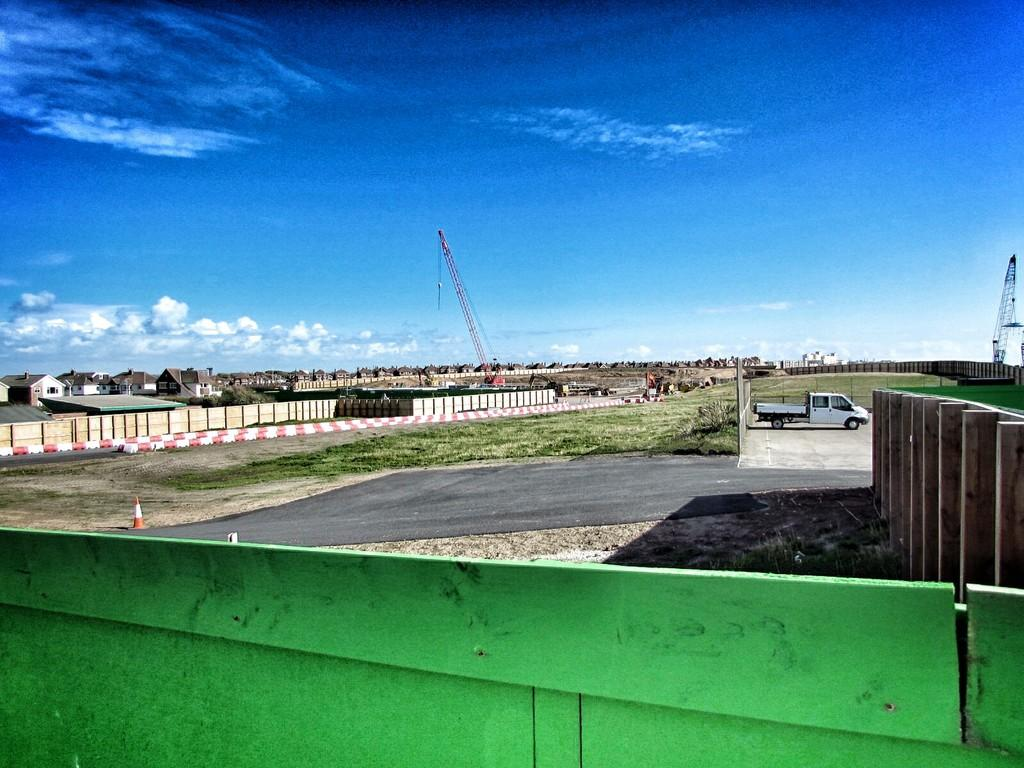What is located on the right side of the image? There is a truck on the right side of the image. What can be seen in the background of the image? There are buildings in the left side background of the image. What is the condition of the sky in the image? The sky is clear in the image. What is present on the left side of the image? The wall is located on the left side of the image. Can you tell me how many cups of coffee the mother is holding in the image? There is no mother or cup of coffee present in the image. What type of help is being provided by the person in the image? There is no person or indication of help being provided in the image. 